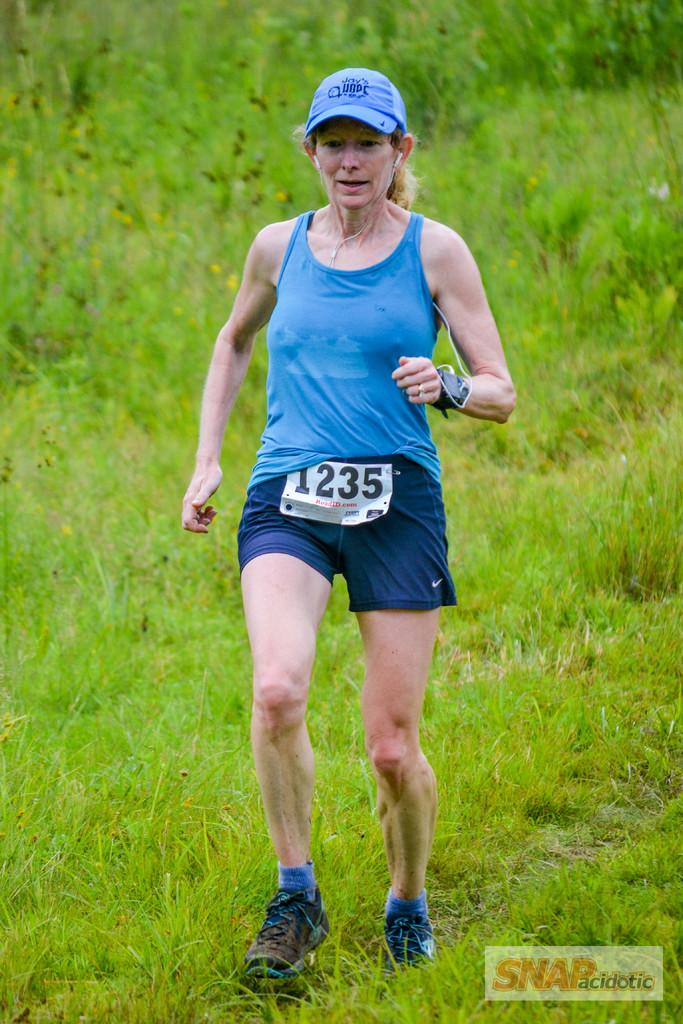Provide a one-sentence caption for the provided image. A woman runs cross country wearing the number 1235. 